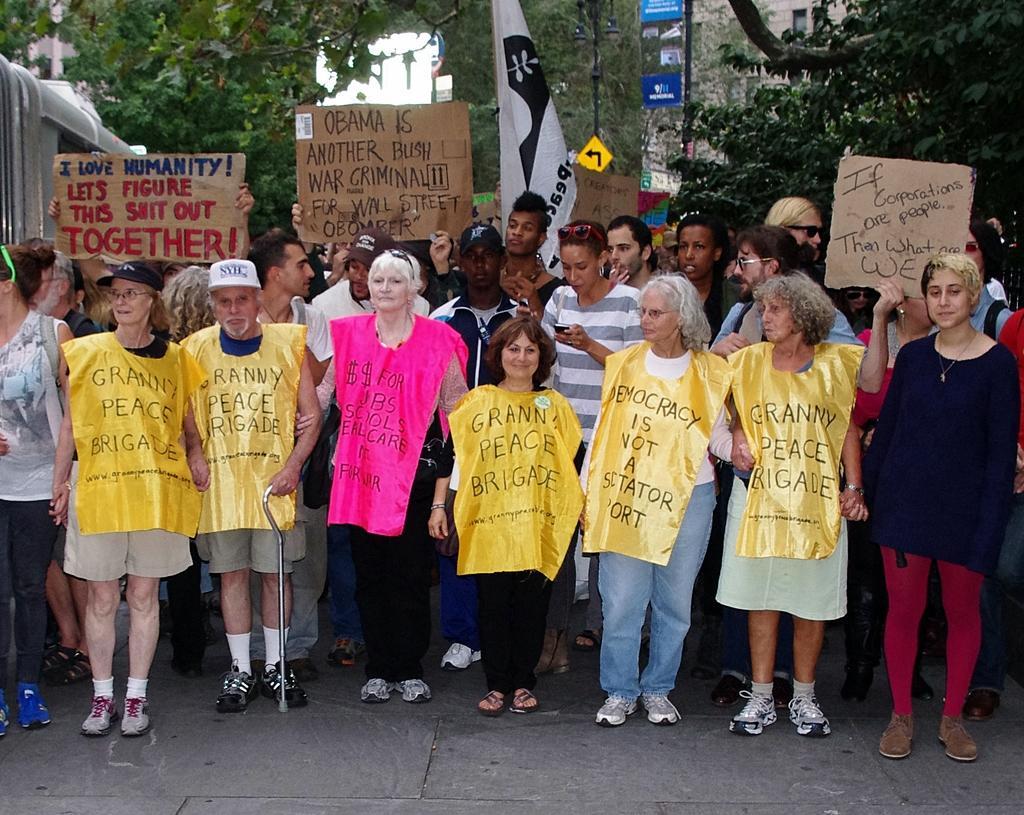Could you give a brief overview of what you see in this image? At the bottom of the image there is floor. On the floor there are few people standing and they are wearing yellow and pink color covers. There are few people holding the cardboard in their hands and there is something written on it. In the background there are trees, poles with sign boards. 